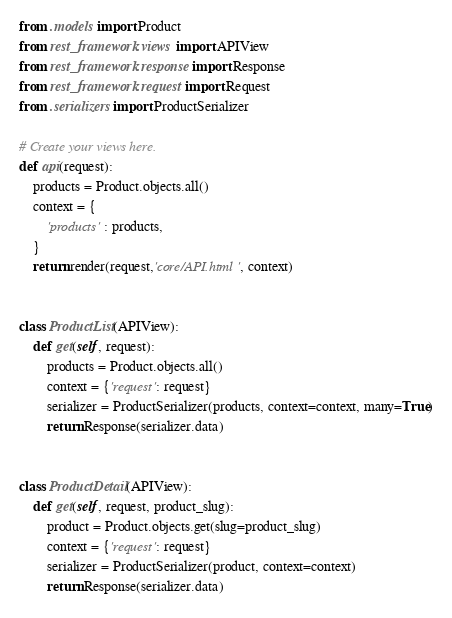<code> <loc_0><loc_0><loc_500><loc_500><_Python_>from .models import Product
from rest_framework.views import APIView
from rest_framework.response import Response
from rest_framework.request import Request
from .serializers import ProductSerializer

# Create your views here.
def api(request):
    products = Product.objects.all()
    context = {
        'products' : products,
    }
    return render(request,'core/API.html', context)


class ProductList(APIView):
    def get(self, request):
        products = Product.objects.all()
        context = {'request': request}
        serializer = ProductSerializer(products, context=context, many=True)
        return Response(serializer.data)


class ProductDetail(APIView):
    def get(self, request, product_slug):
        product = Product.objects.get(slug=product_slug)
        context = {'request': request}
        serializer = ProductSerializer(product, context=context)
        return Response(serializer.data)
</code> 